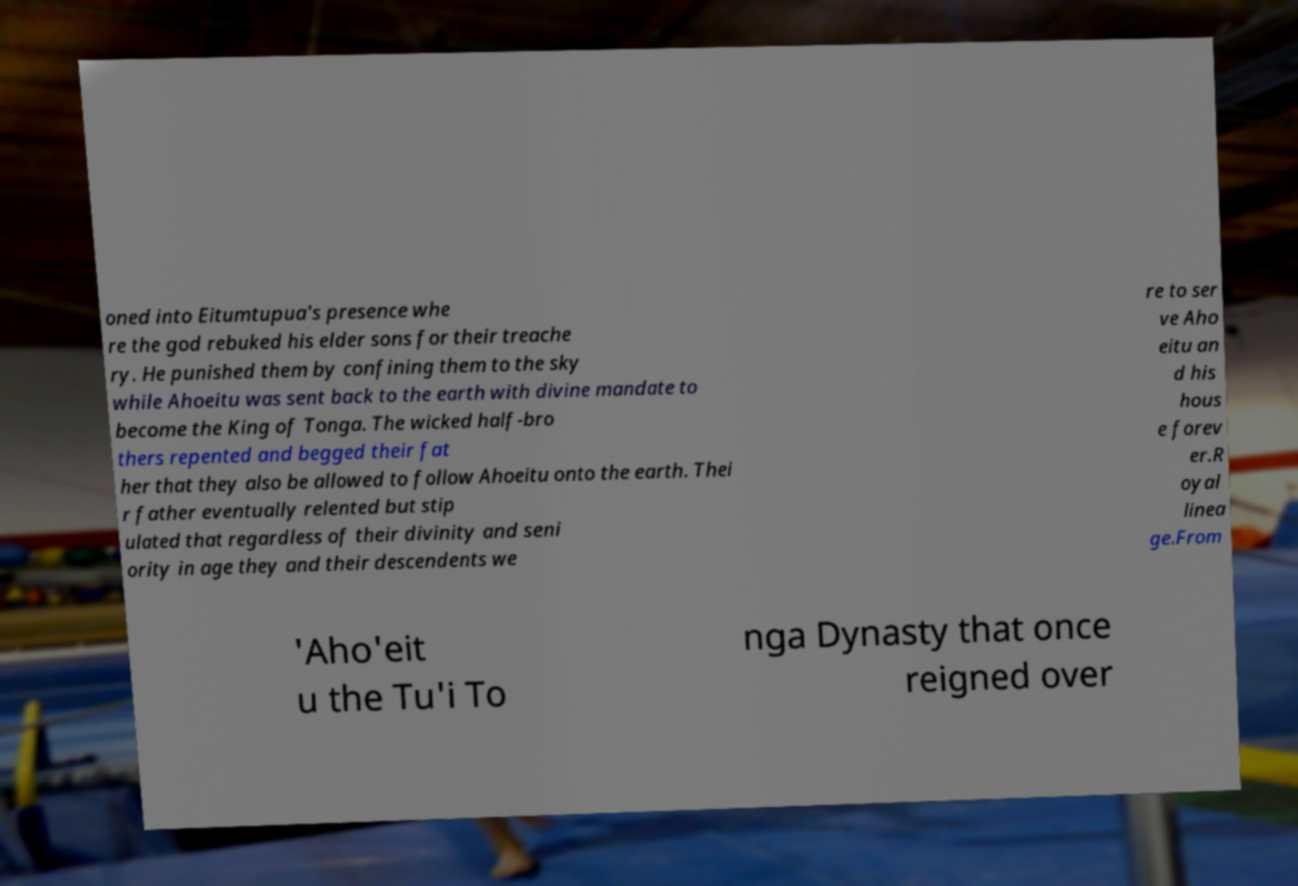Can you read and provide the text displayed in the image?This photo seems to have some interesting text. Can you extract and type it out for me? oned into Eitumtupua's presence whe re the god rebuked his elder sons for their treache ry. He punished them by confining them to the sky while Ahoeitu was sent back to the earth with divine mandate to become the King of Tonga. The wicked half-bro thers repented and begged their fat her that they also be allowed to follow Ahoeitu onto the earth. Thei r father eventually relented but stip ulated that regardless of their divinity and seni ority in age they and their descendents we re to ser ve Aho eitu an d his hous e forev er.R oyal linea ge.From 'Aho'eit u the Tu'i To nga Dynasty that once reigned over 